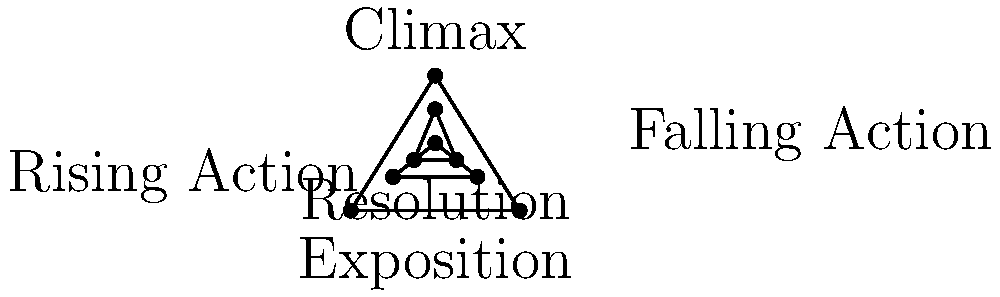Analyze the given plot structure pyramid diagram and explain how it relates to the development of tension in a novel. Which element of the diagram would likely contain the most intense conflict, and why is this significant for a debut author crafting their first novel? To analyze the plot structure pyramid diagram and its relation to tension development in a novel, let's break it down step-by-step:

1. The diagram represents the classic five-act structure of a story:
   a) Exposition
   b) Rising Action
   c) Climax
   d) Falling Action
   e) Resolution

2. Tension development:
   a) Exposition: Introduces characters and setting, establishing the baseline tension.
   b) Rising Action: Tension gradually increases as conflicts and obstacles are introduced.
   c) Climax: The point of highest tension and most intense conflict.
   d) Falling Action: Tension begins to decrease as conflicts are addressed.
   e) Resolution: Tension is largely resolved, returning to a new equilibrium.

3. The element containing the most intense conflict is the Climax, located at the top of the pyramid. This is significant for a debut author because:
   a) It represents the pivotal moment where all preceding conflicts converge.
   b) It's the emotional and narrative peak of the story, often determining reader satisfaction.
   c) Crafting a compelling climax demonstrates the author's ability to build and resolve tension effectively.
   d) A well-executed climax can leave a lasting impression on readers, potentially influencing the success of the debut novel.

4. For a debut author:
   a) Understanding this structure helps in pacing the story and maintaining reader engagement.
   b) It provides a framework for balancing character development, plot progression, and conflict resolution.
   c) Mastering this structure can showcase the author's storytelling skills to potential publishers and readers.

5. The pyramid shape visually represents the rising and falling tension, emphasizing the climax's importance as the highest point of conflict and reader engagement.
Answer: Climax; it's the peak of tension and conflict, crucial for reader engagement and demonstrating the debut author's storytelling skills. 